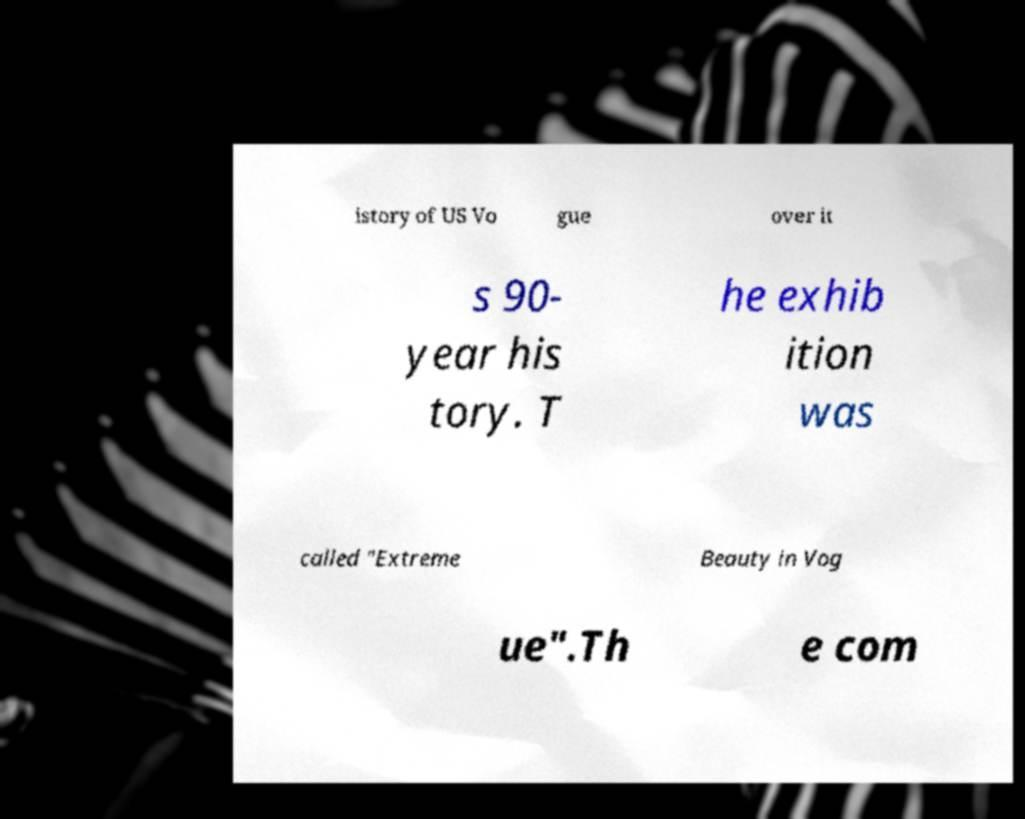Please identify and transcribe the text found in this image. istory of US Vo gue over it s 90- year his tory. T he exhib ition was called "Extreme Beauty in Vog ue".Th e com 